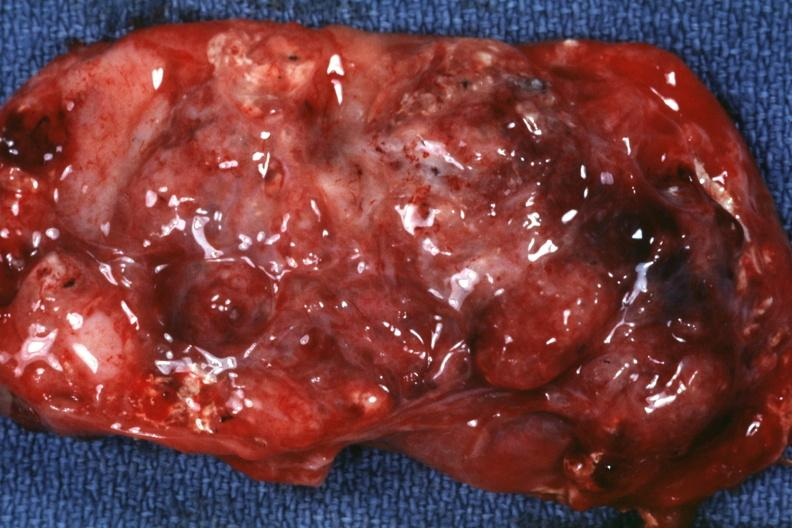s omentum present?
Answer the question using a single word or phrase. No 